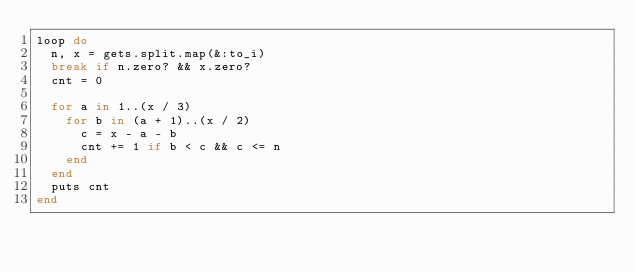Convert code to text. <code><loc_0><loc_0><loc_500><loc_500><_Ruby_>loop do
  n, x = gets.split.map(&:to_i)
  break if n.zero? && x.zero?
  cnt = 0

  for a in 1..(x / 3)
    for b in (a + 1)..(x / 2)
      c = x - a - b
      cnt += 1 if b < c && c <= n
    end
  end
  puts cnt
end
</code> 